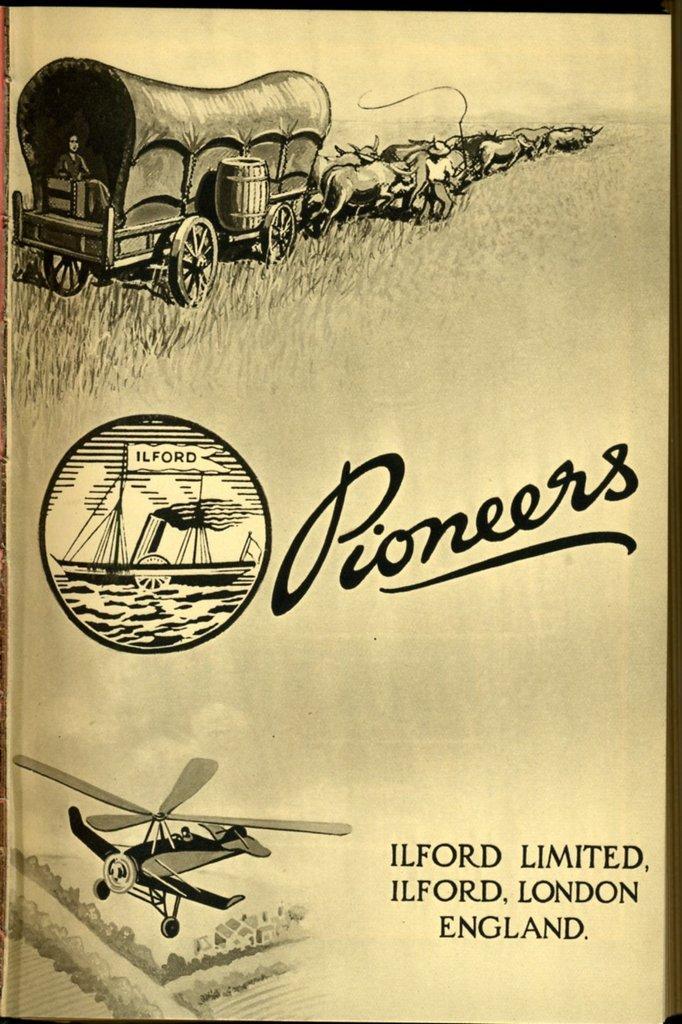Could you give a brief overview of what you see in this image? In this image, there is a picture, on that picture at the middle there is PIONEER is written, at the bottom there is IN FORD LIMITED written, at the top there is a four wheel cart and there are some animal on the picture. 